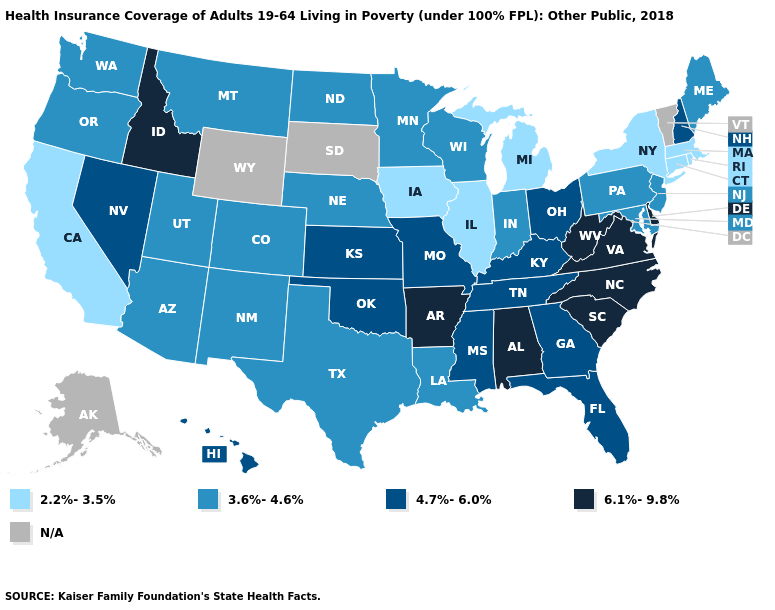Among the states that border Washington , which have the highest value?
Be succinct. Idaho. Name the states that have a value in the range 4.7%-6.0%?
Quick response, please. Florida, Georgia, Hawaii, Kansas, Kentucky, Mississippi, Missouri, Nevada, New Hampshire, Ohio, Oklahoma, Tennessee. Name the states that have a value in the range 6.1%-9.8%?
Write a very short answer. Alabama, Arkansas, Delaware, Idaho, North Carolina, South Carolina, Virginia, West Virginia. What is the value of Hawaii?
Give a very brief answer. 4.7%-6.0%. Which states hav the highest value in the MidWest?
Give a very brief answer. Kansas, Missouri, Ohio. Name the states that have a value in the range 4.7%-6.0%?
Concise answer only. Florida, Georgia, Hawaii, Kansas, Kentucky, Mississippi, Missouri, Nevada, New Hampshire, Ohio, Oklahoma, Tennessee. Does Missouri have the highest value in the MidWest?
Concise answer only. Yes. What is the value of South Dakota?
Write a very short answer. N/A. Which states have the highest value in the USA?
Concise answer only. Alabama, Arkansas, Delaware, Idaho, North Carolina, South Carolina, Virginia, West Virginia. What is the value of California?
Give a very brief answer. 2.2%-3.5%. Is the legend a continuous bar?
Be succinct. No. Name the states that have a value in the range 3.6%-4.6%?
Be succinct. Arizona, Colorado, Indiana, Louisiana, Maine, Maryland, Minnesota, Montana, Nebraska, New Jersey, New Mexico, North Dakota, Oregon, Pennsylvania, Texas, Utah, Washington, Wisconsin. Which states have the lowest value in the MidWest?
Write a very short answer. Illinois, Iowa, Michigan. How many symbols are there in the legend?
Short answer required. 5. Name the states that have a value in the range 3.6%-4.6%?
Short answer required. Arizona, Colorado, Indiana, Louisiana, Maine, Maryland, Minnesota, Montana, Nebraska, New Jersey, New Mexico, North Dakota, Oregon, Pennsylvania, Texas, Utah, Washington, Wisconsin. 